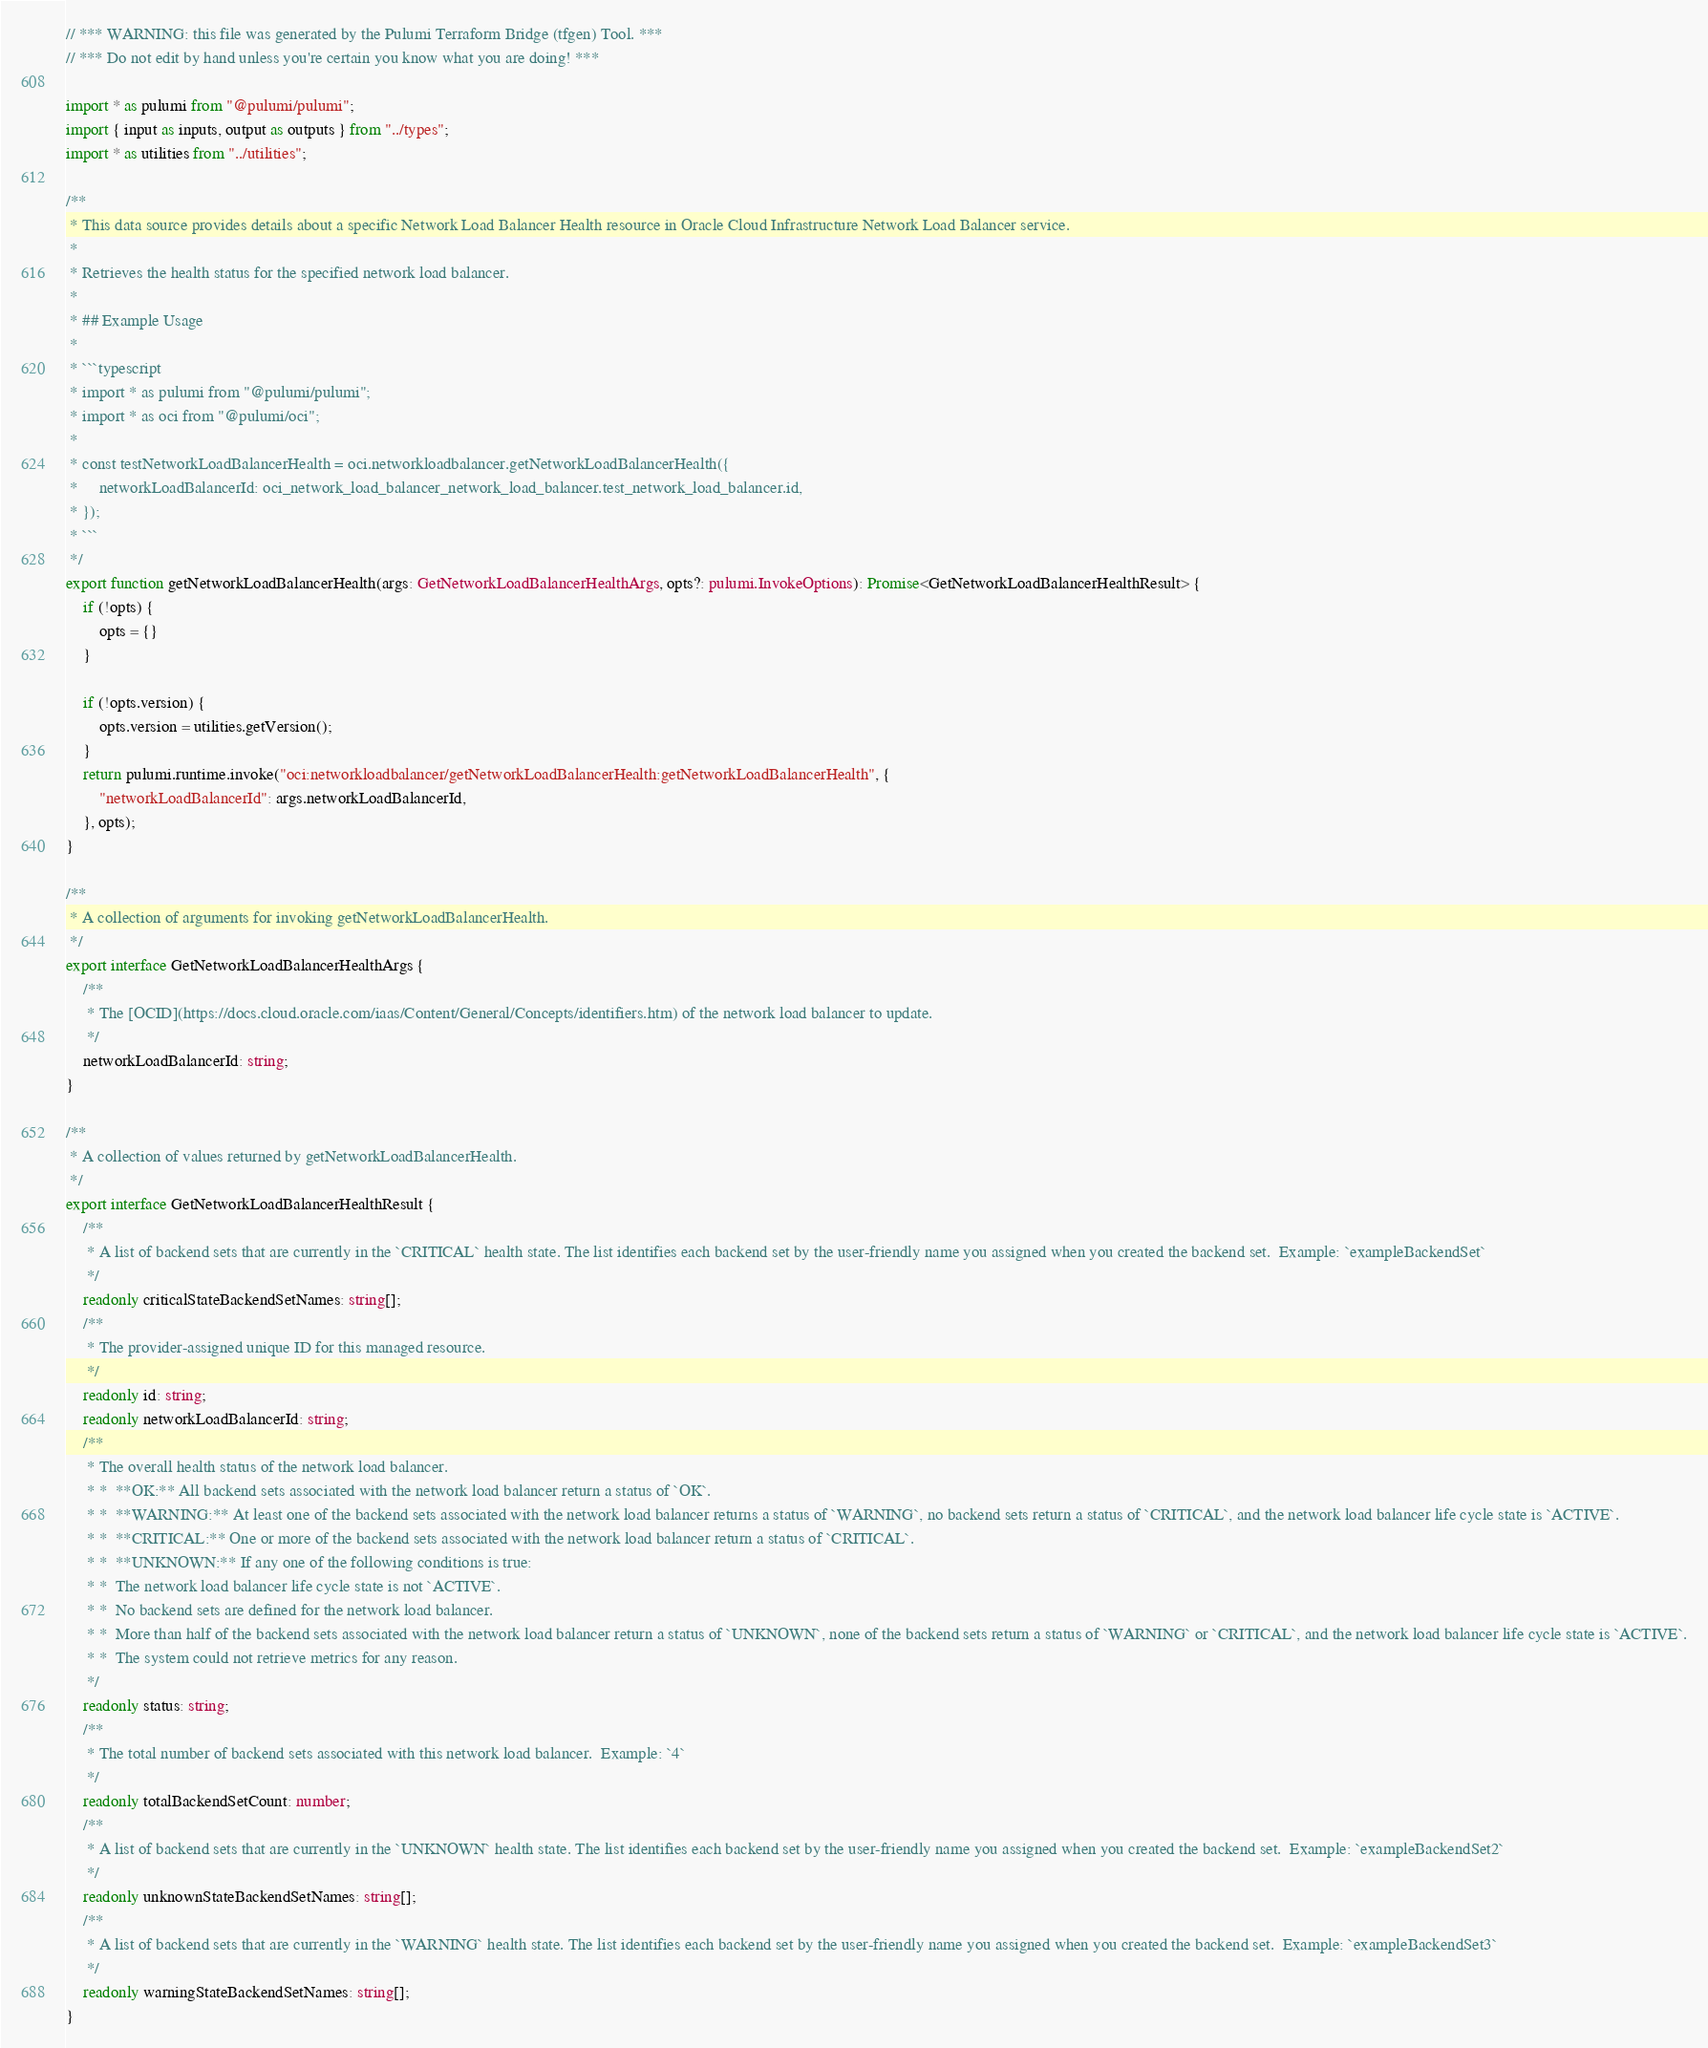<code> <loc_0><loc_0><loc_500><loc_500><_TypeScript_>// *** WARNING: this file was generated by the Pulumi Terraform Bridge (tfgen) Tool. ***
// *** Do not edit by hand unless you're certain you know what you are doing! ***

import * as pulumi from "@pulumi/pulumi";
import { input as inputs, output as outputs } from "../types";
import * as utilities from "../utilities";

/**
 * This data source provides details about a specific Network Load Balancer Health resource in Oracle Cloud Infrastructure Network Load Balancer service.
 *
 * Retrieves the health status for the specified network load balancer.
 *
 * ## Example Usage
 *
 * ```typescript
 * import * as pulumi from "@pulumi/pulumi";
 * import * as oci from "@pulumi/oci";
 *
 * const testNetworkLoadBalancerHealth = oci.networkloadbalancer.getNetworkLoadBalancerHealth({
 *     networkLoadBalancerId: oci_network_load_balancer_network_load_balancer.test_network_load_balancer.id,
 * });
 * ```
 */
export function getNetworkLoadBalancerHealth(args: GetNetworkLoadBalancerHealthArgs, opts?: pulumi.InvokeOptions): Promise<GetNetworkLoadBalancerHealthResult> {
    if (!opts) {
        opts = {}
    }

    if (!opts.version) {
        opts.version = utilities.getVersion();
    }
    return pulumi.runtime.invoke("oci:networkloadbalancer/getNetworkLoadBalancerHealth:getNetworkLoadBalancerHealth", {
        "networkLoadBalancerId": args.networkLoadBalancerId,
    }, opts);
}

/**
 * A collection of arguments for invoking getNetworkLoadBalancerHealth.
 */
export interface GetNetworkLoadBalancerHealthArgs {
    /**
     * The [OCID](https://docs.cloud.oracle.com/iaas/Content/General/Concepts/identifiers.htm) of the network load balancer to update.
     */
    networkLoadBalancerId: string;
}

/**
 * A collection of values returned by getNetworkLoadBalancerHealth.
 */
export interface GetNetworkLoadBalancerHealthResult {
    /**
     * A list of backend sets that are currently in the `CRITICAL` health state. The list identifies each backend set by the user-friendly name you assigned when you created the backend set.  Example: `exampleBackendSet`
     */
    readonly criticalStateBackendSetNames: string[];
    /**
     * The provider-assigned unique ID for this managed resource.
     */
    readonly id: string;
    readonly networkLoadBalancerId: string;
    /**
     * The overall health status of the network load balancer.
     * *  **OK:** All backend sets associated with the network load balancer return a status of `OK`.
     * *  **WARNING:** At least one of the backend sets associated with the network load balancer returns a status of `WARNING`, no backend sets return a status of `CRITICAL`, and the network load balancer life cycle state is `ACTIVE`.
     * *  **CRITICAL:** One or more of the backend sets associated with the network load balancer return a status of `CRITICAL`.
     * *  **UNKNOWN:** If any one of the following conditions is true:
     * *  The network load balancer life cycle state is not `ACTIVE`.
     * *  No backend sets are defined for the network load balancer.
     * *  More than half of the backend sets associated with the network load balancer return a status of `UNKNOWN`, none of the backend sets return a status of `WARNING` or `CRITICAL`, and the network load balancer life cycle state is `ACTIVE`.
     * *  The system could not retrieve metrics for any reason.
     */
    readonly status: string;
    /**
     * The total number of backend sets associated with this network load balancer.  Example: `4`
     */
    readonly totalBackendSetCount: number;
    /**
     * A list of backend sets that are currently in the `UNKNOWN` health state. The list identifies each backend set by the user-friendly name you assigned when you created the backend set.  Example: `exampleBackendSet2`
     */
    readonly unknownStateBackendSetNames: string[];
    /**
     * A list of backend sets that are currently in the `WARNING` health state. The list identifies each backend set by the user-friendly name you assigned when you created the backend set.  Example: `exampleBackendSet3`
     */
    readonly warningStateBackendSetNames: string[];
}
</code> 